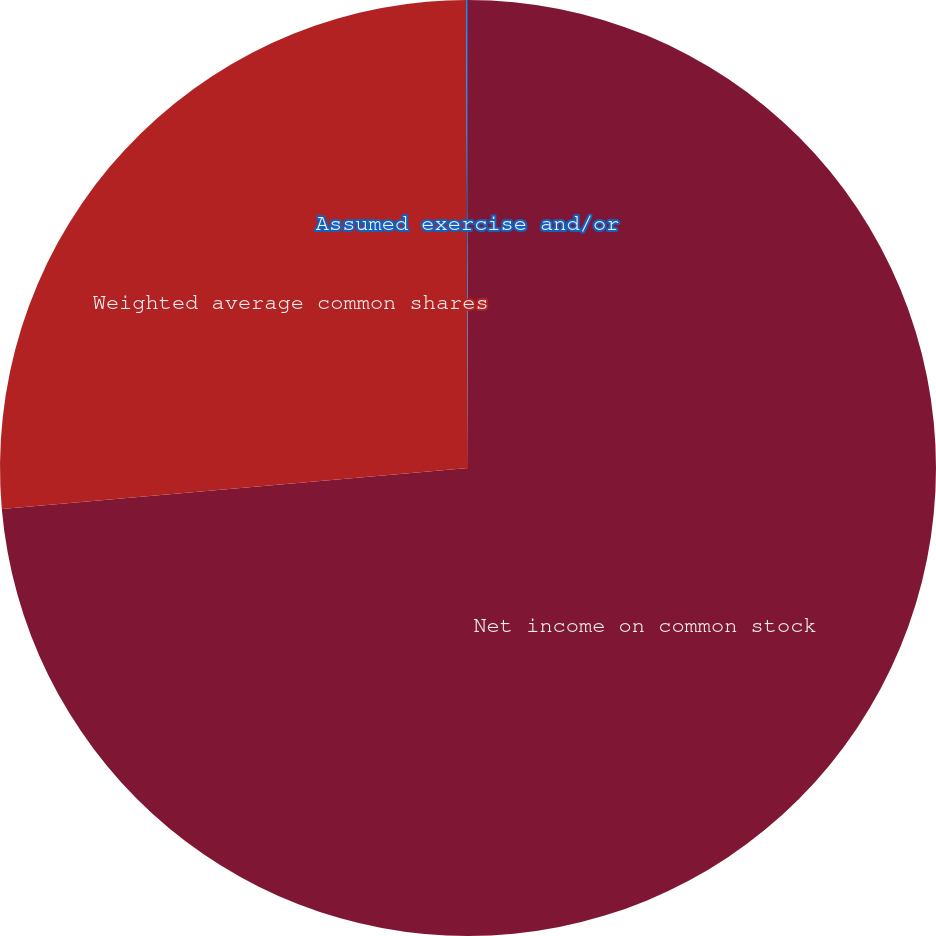Convert chart to OTSL. <chart><loc_0><loc_0><loc_500><loc_500><pie_chart><fcel>Net income on common stock<fcel>Weighted average common shares<fcel>Assumed exercise and/or<nl><fcel>73.61%<fcel>26.34%<fcel>0.06%<nl></chart> 